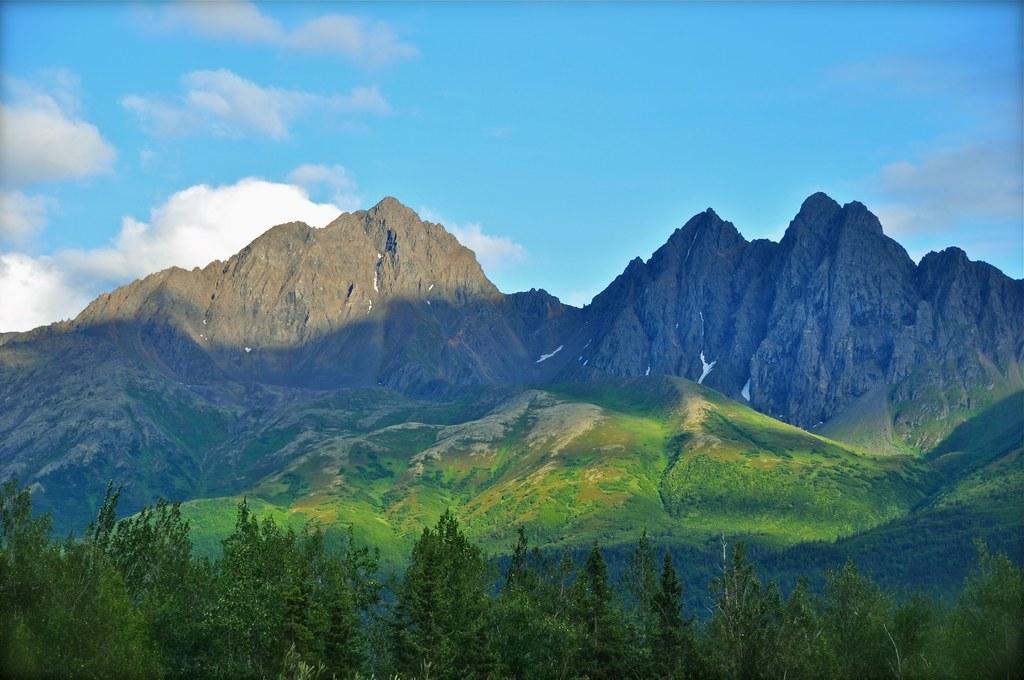In one or two sentences, can you explain what this image depicts? It is a beautiful scenery with a lot of trees and grass on the mountains and in the background there are two huge mountains filled with mud and the climate is very pleasant. 